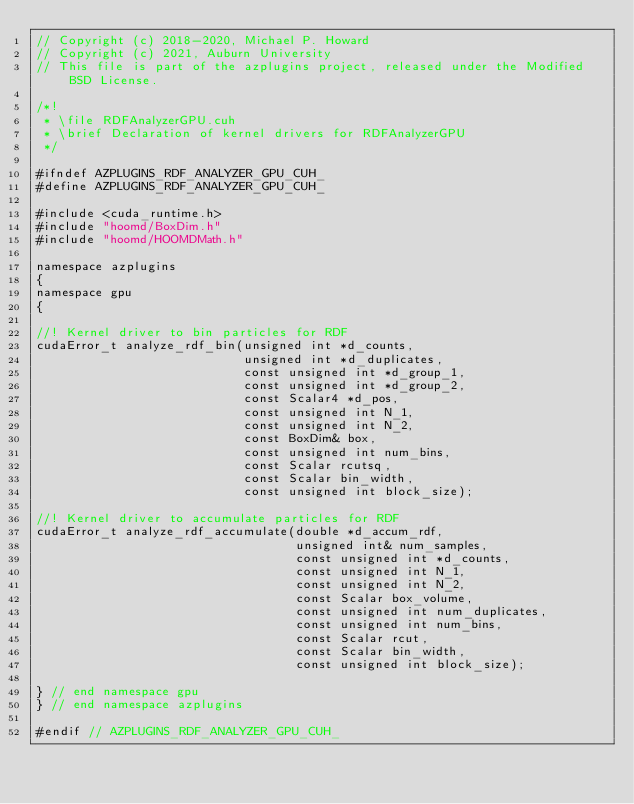<code> <loc_0><loc_0><loc_500><loc_500><_Cuda_>// Copyright (c) 2018-2020, Michael P. Howard
// Copyright (c) 2021, Auburn University
// This file is part of the azplugins project, released under the Modified BSD License.

/*!
 * \file RDFAnalyzerGPU.cuh
 * \brief Declaration of kernel drivers for RDFAnalyzerGPU
 */

#ifndef AZPLUGINS_RDF_ANALYZER_GPU_CUH_
#define AZPLUGINS_RDF_ANALYZER_GPU_CUH_

#include <cuda_runtime.h>
#include "hoomd/BoxDim.h"
#include "hoomd/HOOMDMath.h"

namespace azplugins
{
namespace gpu
{

//! Kernel driver to bin particles for RDF
cudaError_t analyze_rdf_bin(unsigned int *d_counts,
                            unsigned int *d_duplicates,
                            const unsigned int *d_group_1,
                            const unsigned int *d_group_2,
                            const Scalar4 *d_pos,
                            const unsigned int N_1,
                            const unsigned int N_2,
                            const BoxDim& box,
                            const unsigned int num_bins,
                            const Scalar rcutsq,
                            const Scalar bin_width,
                            const unsigned int block_size);

//! Kernel driver to accumulate particles for RDF
cudaError_t analyze_rdf_accumulate(double *d_accum_rdf,
                                   unsigned int& num_samples,
                                   const unsigned int *d_counts,
                                   const unsigned int N_1,
                                   const unsigned int N_2,
                                   const Scalar box_volume,
                                   const unsigned int num_duplicates,
                                   const unsigned int num_bins,
                                   const Scalar rcut,
                                   const Scalar bin_width,
                                   const unsigned int block_size);

} // end namespace gpu
} // end namespace azplugins

#endif // AZPLUGINS_RDF_ANALYZER_GPU_CUH_
</code> 